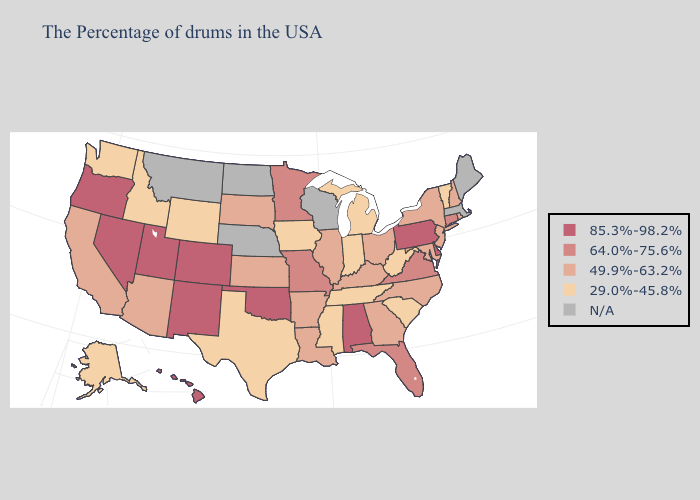Which states have the lowest value in the USA?
Quick response, please. Vermont, South Carolina, West Virginia, Michigan, Indiana, Tennessee, Mississippi, Iowa, Texas, Wyoming, Idaho, Washington, Alaska. What is the value of Indiana?
Keep it brief. 29.0%-45.8%. Name the states that have a value in the range 64.0%-75.6%?
Write a very short answer. Connecticut, Virginia, Florida, Missouri, Minnesota. Name the states that have a value in the range 49.9%-63.2%?
Give a very brief answer. Rhode Island, New Hampshire, New York, New Jersey, Maryland, North Carolina, Ohio, Georgia, Kentucky, Illinois, Louisiana, Arkansas, Kansas, South Dakota, Arizona, California. What is the lowest value in the USA?
Write a very short answer. 29.0%-45.8%. What is the value of Alabama?
Write a very short answer. 85.3%-98.2%. Which states have the highest value in the USA?
Keep it brief. Delaware, Pennsylvania, Alabama, Oklahoma, Colorado, New Mexico, Utah, Nevada, Oregon, Hawaii. Does New Hampshire have the highest value in the Northeast?
Answer briefly. No. Among the states that border Pennsylvania , does West Virginia have the lowest value?
Concise answer only. Yes. What is the value of Alabama?
Keep it brief. 85.3%-98.2%. 